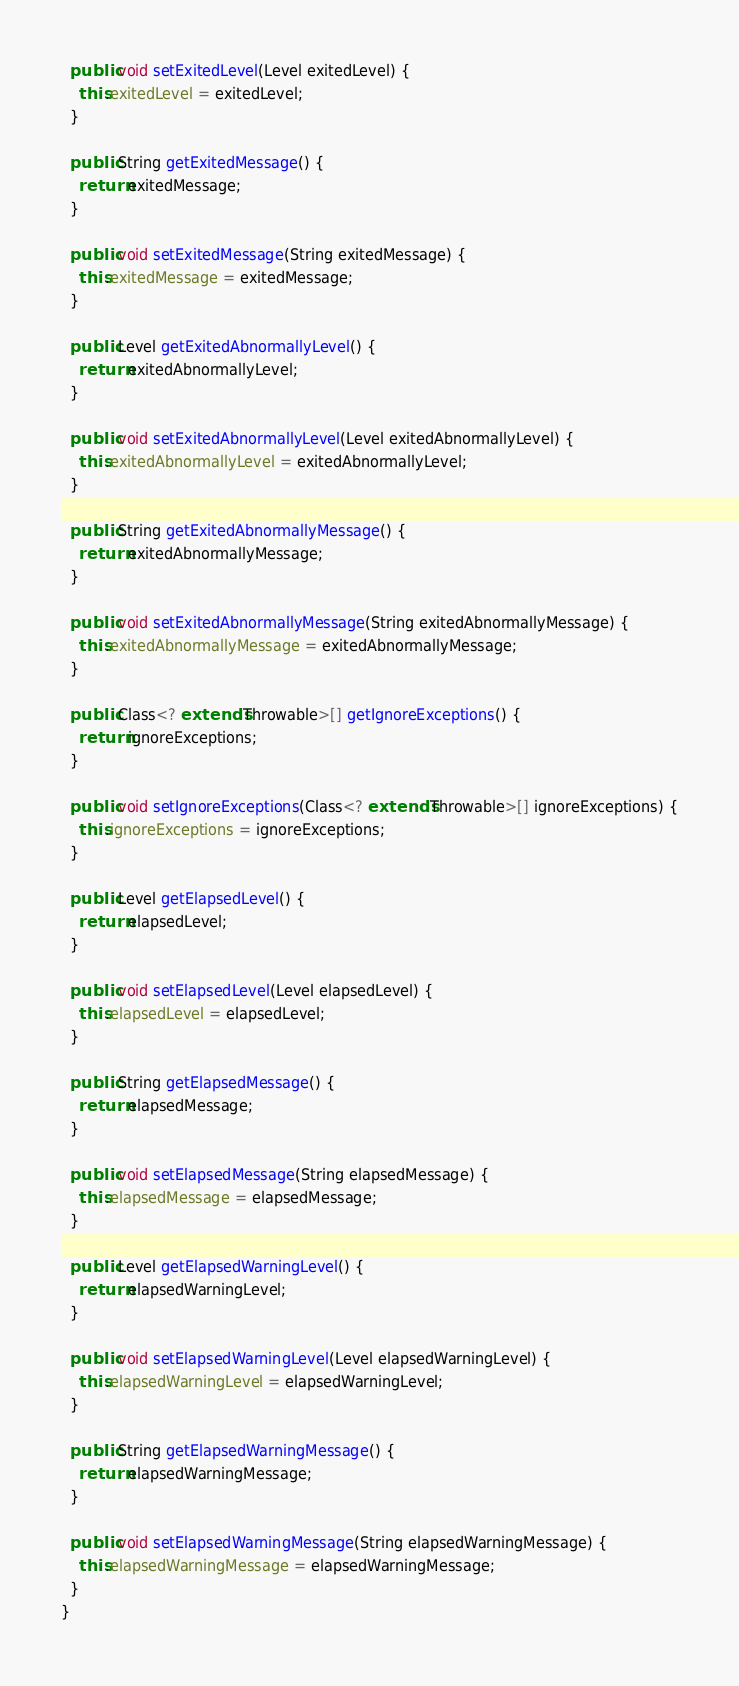<code> <loc_0><loc_0><loc_500><loc_500><_Java_>  public void setExitedLevel(Level exitedLevel) {
    this.exitedLevel = exitedLevel;
  }

  public String getExitedMessage() {
    return exitedMessage;
  }

  public void setExitedMessage(String exitedMessage) {
    this.exitedMessage = exitedMessage;
  }

  public Level getExitedAbnormallyLevel() {
    return exitedAbnormallyLevel;
  }

  public void setExitedAbnormallyLevel(Level exitedAbnormallyLevel) {
    this.exitedAbnormallyLevel = exitedAbnormallyLevel;
  }

  public String getExitedAbnormallyMessage() {
    return exitedAbnormallyMessage;
  }

  public void setExitedAbnormallyMessage(String exitedAbnormallyMessage) {
    this.exitedAbnormallyMessage = exitedAbnormallyMessage;
  }

  public Class<? extends Throwable>[] getIgnoreExceptions() {
    return ignoreExceptions;
  }

  public void setIgnoreExceptions(Class<? extends Throwable>[] ignoreExceptions) {
    this.ignoreExceptions = ignoreExceptions;
  }

  public Level getElapsedLevel() {
    return elapsedLevel;
  }

  public void setElapsedLevel(Level elapsedLevel) {
    this.elapsedLevel = elapsedLevel;
  }

  public String getElapsedMessage() {
    return elapsedMessage;
  }

  public void setElapsedMessage(String elapsedMessage) {
    this.elapsedMessage = elapsedMessage;
  }

  public Level getElapsedWarningLevel() {
    return elapsedWarningLevel;
  }

  public void setElapsedWarningLevel(Level elapsedWarningLevel) {
    this.elapsedWarningLevel = elapsedWarningLevel;
  }

  public String getElapsedWarningMessage() {
    return elapsedWarningMessage;
  }

  public void setElapsedWarningMessage(String elapsedWarningMessage) {
    this.elapsedWarningMessage = elapsedWarningMessage;
  }
}
</code> 